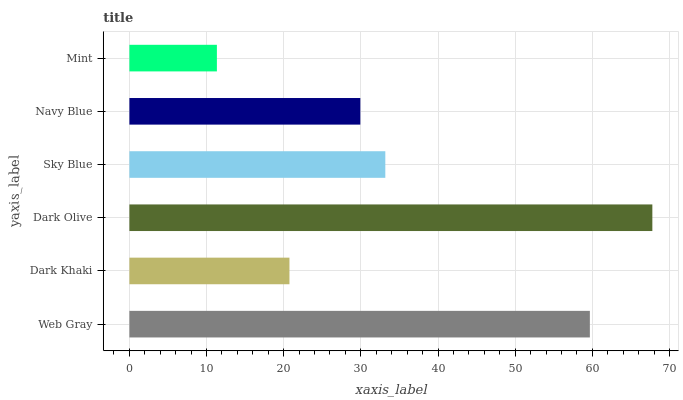Is Mint the minimum?
Answer yes or no. Yes. Is Dark Olive the maximum?
Answer yes or no. Yes. Is Dark Khaki the minimum?
Answer yes or no. No. Is Dark Khaki the maximum?
Answer yes or no. No. Is Web Gray greater than Dark Khaki?
Answer yes or no. Yes. Is Dark Khaki less than Web Gray?
Answer yes or no. Yes. Is Dark Khaki greater than Web Gray?
Answer yes or no. No. Is Web Gray less than Dark Khaki?
Answer yes or no. No. Is Sky Blue the high median?
Answer yes or no. Yes. Is Navy Blue the low median?
Answer yes or no. Yes. Is Dark Khaki the high median?
Answer yes or no. No. Is Dark Olive the low median?
Answer yes or no. No. 